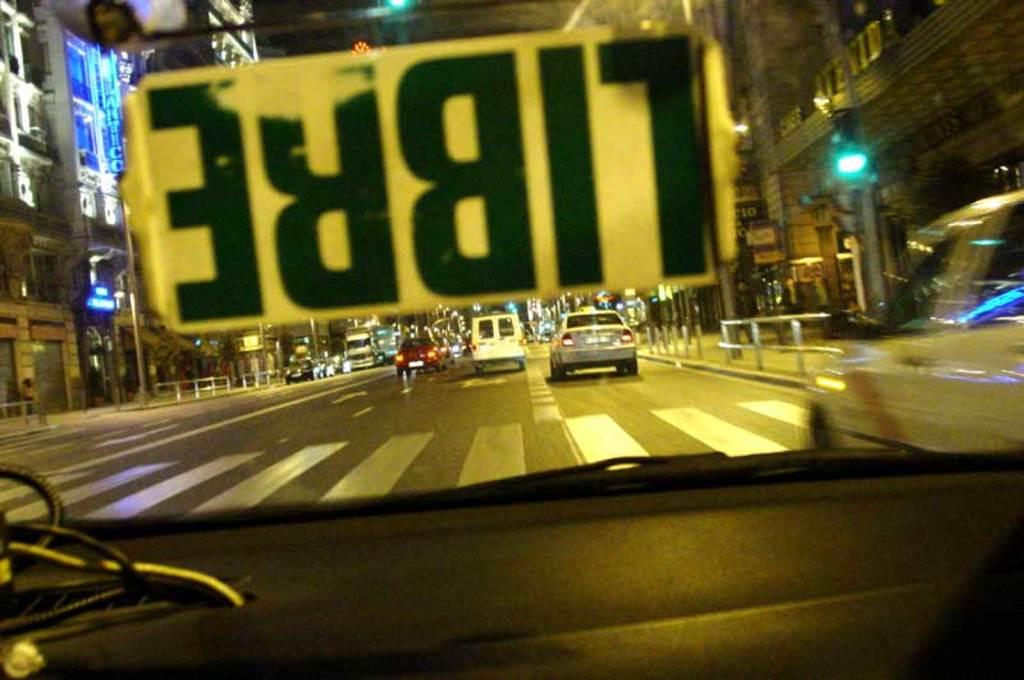<image>
Create a compact narrative representing the image presented. An upside-down sign in a car windshield says LIBRE. 